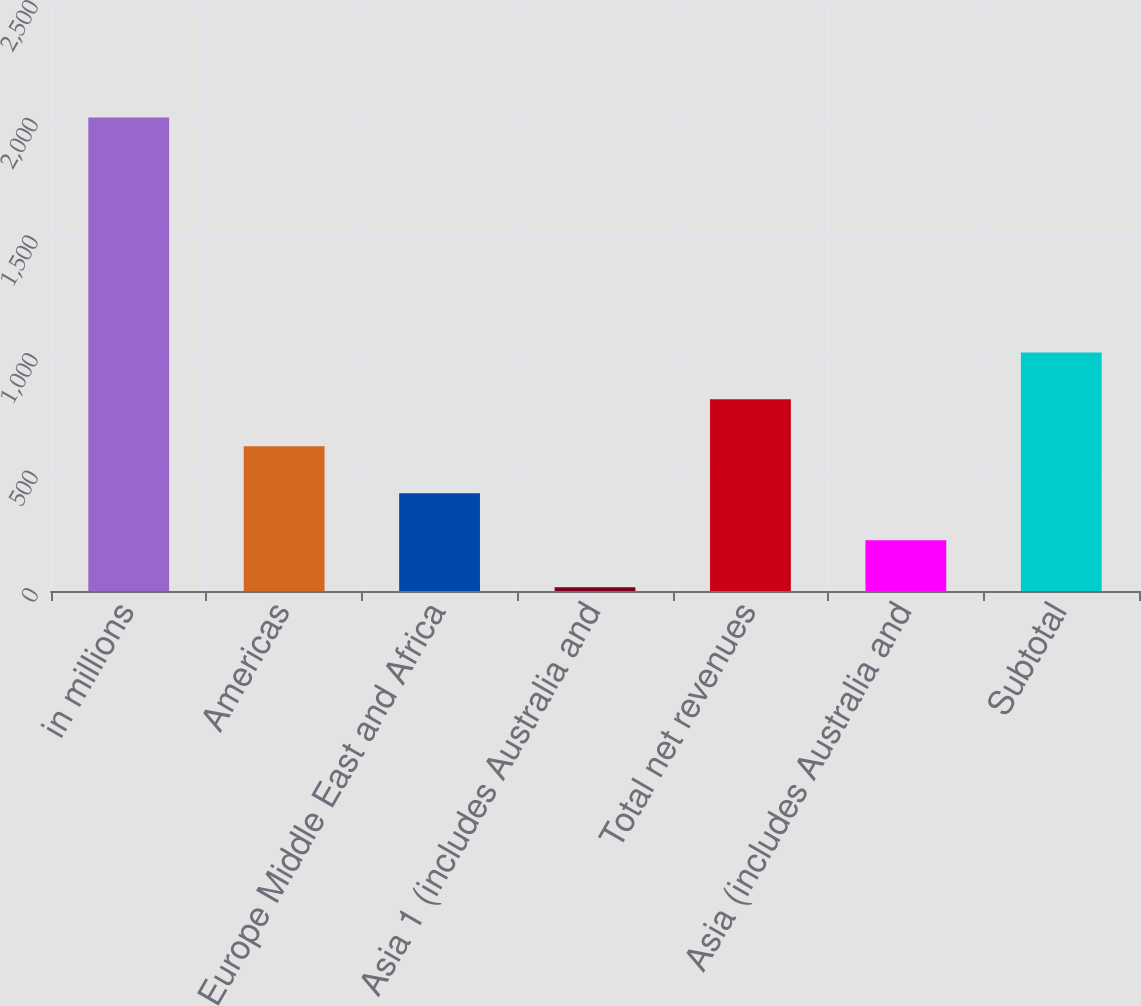Convert chart. <chart><loc_0><loc_0><loc_500><loc_500><bar_chart><fcel>in millions<fcel>Americas<fcel>Europe Middle East and Africa<fcel>Asia 1 (includes Australia and<fcel>Total net revenues<fcel>Asia (includes Australia and<fcel>Subtotal<nl><fcel>2013<fcel>615.1<fcel>415.4<fcel>16<fcel>814.8<fcel>215.7<fcel>1014.5<nl></chart> 